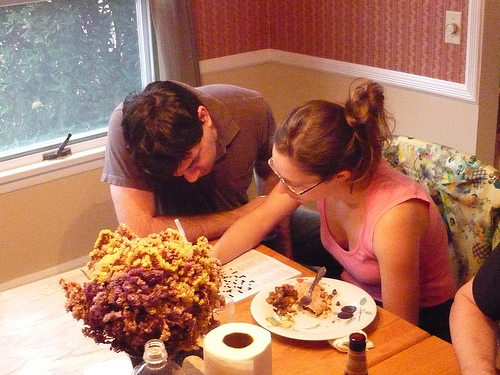<image>
Is there a food behind the woman? No. The food is not behind the woman. From this viewpoint, the food appears to be positioned elsewhere in the scene. Is there a man behind the window? No. The man is not behind the window. From this viewpoint, the man appears to be positioned elsewhere in the scene. 